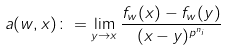<formula> <loc_0><loc_0><loc_500><loc_500>a ( w , x ) \colon = \lim _ { y \to x } \frac { f _ { w } ( x ) - f _ { w } ( y ) } { ( x - y ) ^ { p ^ { n _ { i } } } }</formula> 